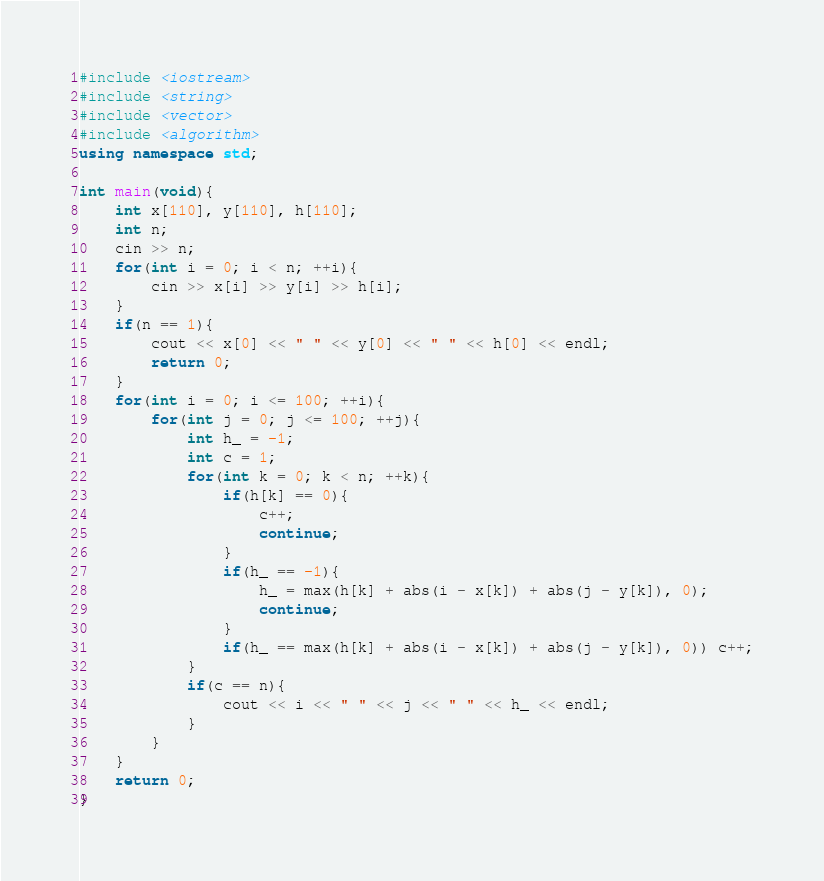<code> <loc_0><loc_0><loc_500><loc_500><_C++_>#include <iostream>
#include <string>
#include <vector>
#include <algorithm>
using namespace std;

int main(void){
	int x[110], y[110], h[110];
	int n;
	cin >> n;
	for(int i = 0; i < n; ++i){
		cin >> x[i] >> y[i] >> h[i];
	}
	if(n == 1){
		cout << x[0] << " " << y[0] << " " << h[0] << endl;
		return 0;
	}
	for(int i = 0; i <= 100; ++i){
		for(int j = 0; j <= 100; ++j){
			int h_ = -1;
			int c = 1;
			for(int k = 0; k < n; ++k){
				if(h[k] == 0){
					c++;
					continue;
				}
				if(h_ == -1){
					h_ = max(h[k] + abs(i - x[k]) + abs(j - y[k]), 0);
					continue;
				}
				if(h_ == max(h[k] + abs(i - x[k]) + abs(j - y[k]), 0)) c++;
			}
			if(c == n){
				cout << i << " " << j << " " << h_ << endl;
			}
		}
	}
	return 0;
}</code> 